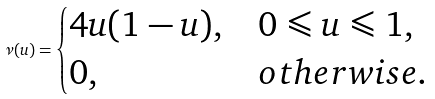Convert formula to latex. <formula><loc_0><loc_0><loc_500><loc_500>\nu ( u ) = \begin{cases} 4 u ( 1 - u ) , & 0 \leqslant u \leqslant 1 , \\ 0 , & o t h e r w i s e . \end{cases}</formula> 